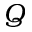<formula> <loc_0><loc_0><loc_500><loc_500>Q</formula> 